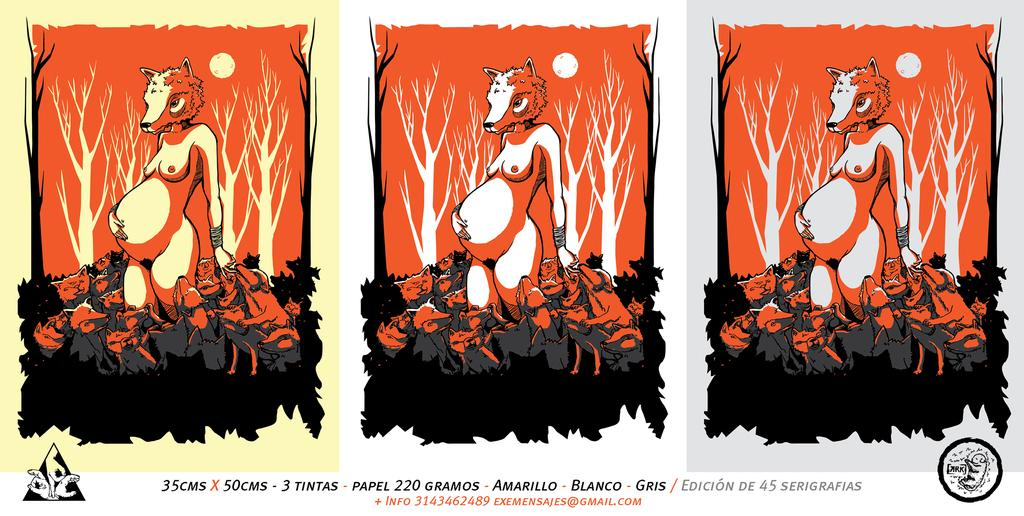Provide a one-sentence caption for the provided image. A cartoon titled 3 tintas with three different background colors. 